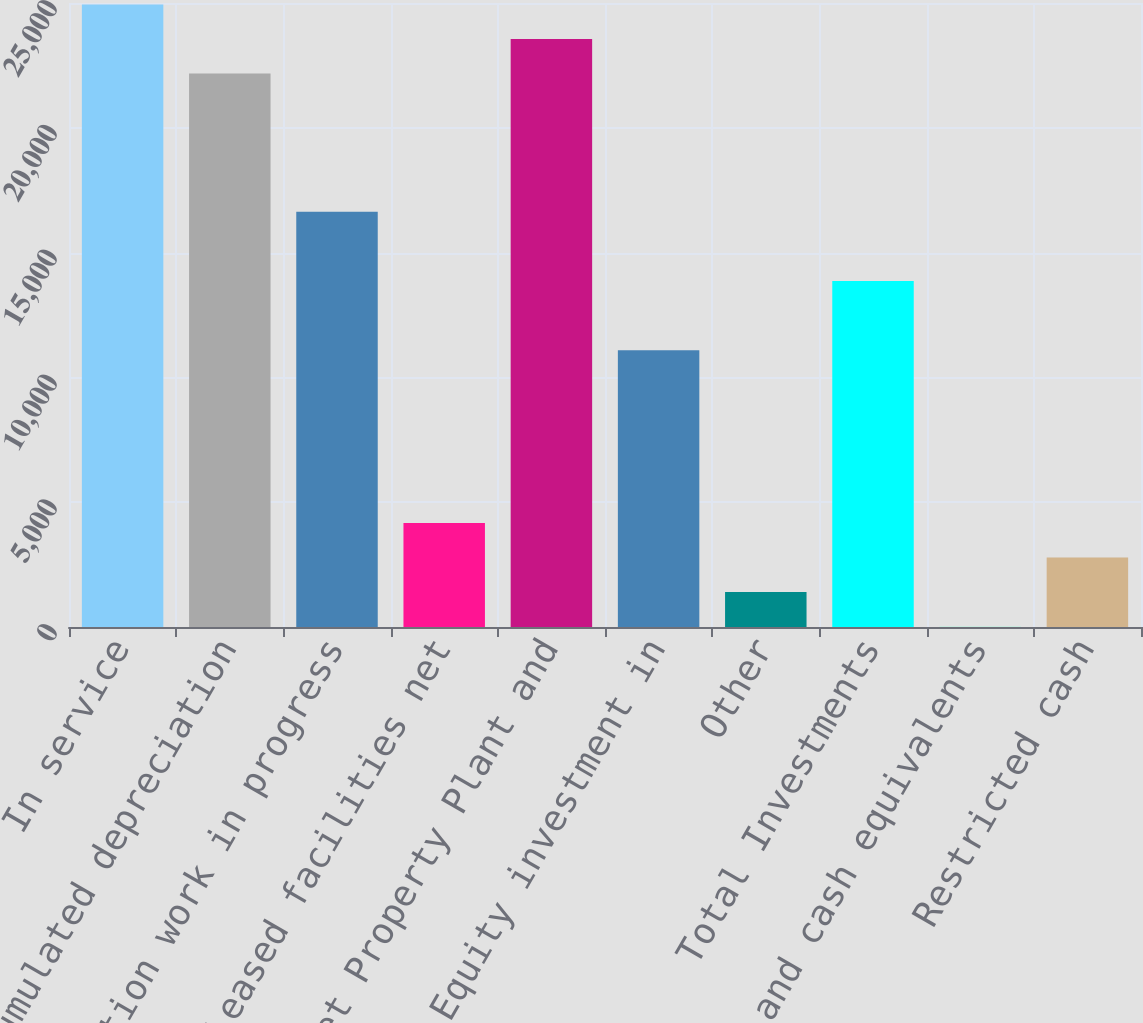<chart> <loc_0><loc_0><loc_500><loc_500><bar_chart><fcel>In service<fcel>Accumulated depreciation<fcel>Construction work in progress<fcel>Leased facilities net<fcel>Net Property Plant and<fcel>Equity investment in<fcel>Other<fcel>Total Investments<fcel>Cash and cash equivalents<fcel>Restricted cash<nl><fcel>24940.5<fcel>22170.9<fcel>16631.7<fcel>4168.5<fcel>23555.7<fcel>11092.5<fcel>1398.9<fcel>13862.1<fcel>14.1<fcel>2783.7<nl></chart> 